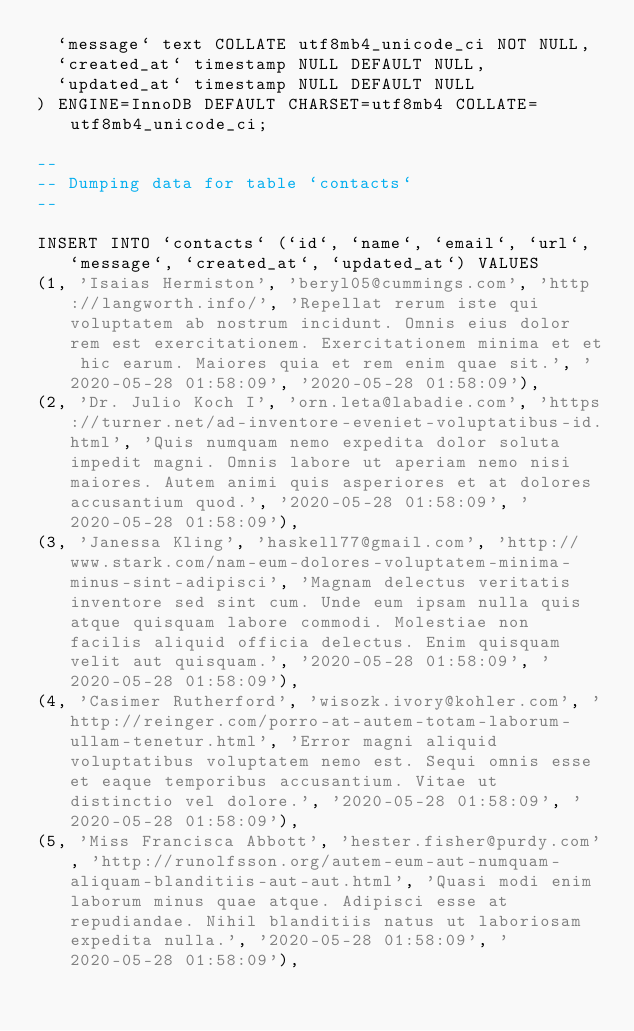Convert code to text. <code><loc_0><loc_0><loc_500><loc_500><_SQL_>  `message` text COLLATE utf8mb4_unicode_ci NOT NULL,
  `created_at` timestamp NULL DEFAULT NULL,
  `updated_at` timestamp NULL DEFAULT NULL
) ENGINE=InnoDB DEFAULT CHARSET=utf8mb4 COLLATE=utf8mb4_unicode_ci;

--
-- Dumping data for table `contacts`
--

INSERT INTO `contacts` (`id`, `name`, `email`, `url`, `message`, `created_at`, `updated_at`) VALUES
(1, 'Isaias Hermiston', 'beryl05@cummings.com', 'http://langworth.info/', 'Repellat rerum iste qui voluptatem ab nostrum incidunt. Omnis eius dolor rem est exercitationem. Exercitationem minima et et hic earum. Maiores quia et rem enim quae sit.', '2020-05-28 01:58:09', '2020-05-28 01:58:09'),
(2, 'Dr. Julio Koch I', 'orn.leta@labadie.com', 'https://turner.net/ad-inventore-eveniet-voluptatibus-id.html', 'Quis numquam nemo expedita dolor soluta impedit magni. Omnis labore ut aperiam nemo nisi maiores. Autem animi quis asperiores et at dolores accusantium quod.', '2020-05-28 01:58:09', '2020-05-28 01:58:09'),
(3, 'Janessa Kling', 'haskell77@gmail.com', 'http://www.stark.com/nam-eum-dolores-voluptatem-minima-minus-sint-adipisci', 'Magnam delectus veritatis inventore sed sint cum. Unde eum ipsam nulla quis atque quisquam labore commodi. Molestiae non facilis aliquid officia delectus. Enim quisquam velit aut quisquam.', '2020-05-28 01:58:09', '2020-05-28 01:58:09'),
(4, 'Casimer Rutherford', 'wisozk.ivory@kohler.com', 'http://reinger.com/porro-at-autem-totam-laborum-ullam-tenetur.html', 'Error magni aliquid voluptatibus voluptatem nemo est. Sequi omnis esse et eaque temporibus accusantium. Vitae ut distinctio vel dolore.', '2020-05-28 01:58:09', '2020-05-28 01:58:09'),
(5, 'Miss Francisca Abbott', 'hester.fisher@purdy.com', 'http://runolfsson.org/autem-eum-aut-numquam-aliquam-blanditiis-aut-aut.html', 'Quasi modi enim laborum minus quae atque. Adipisci esse at repudiandae. Nihil blanditiis natus ut laboriosam expedita nulla.', '2020-05-28 01:58:09', '2020-05-28 01:58:09'),</code> 